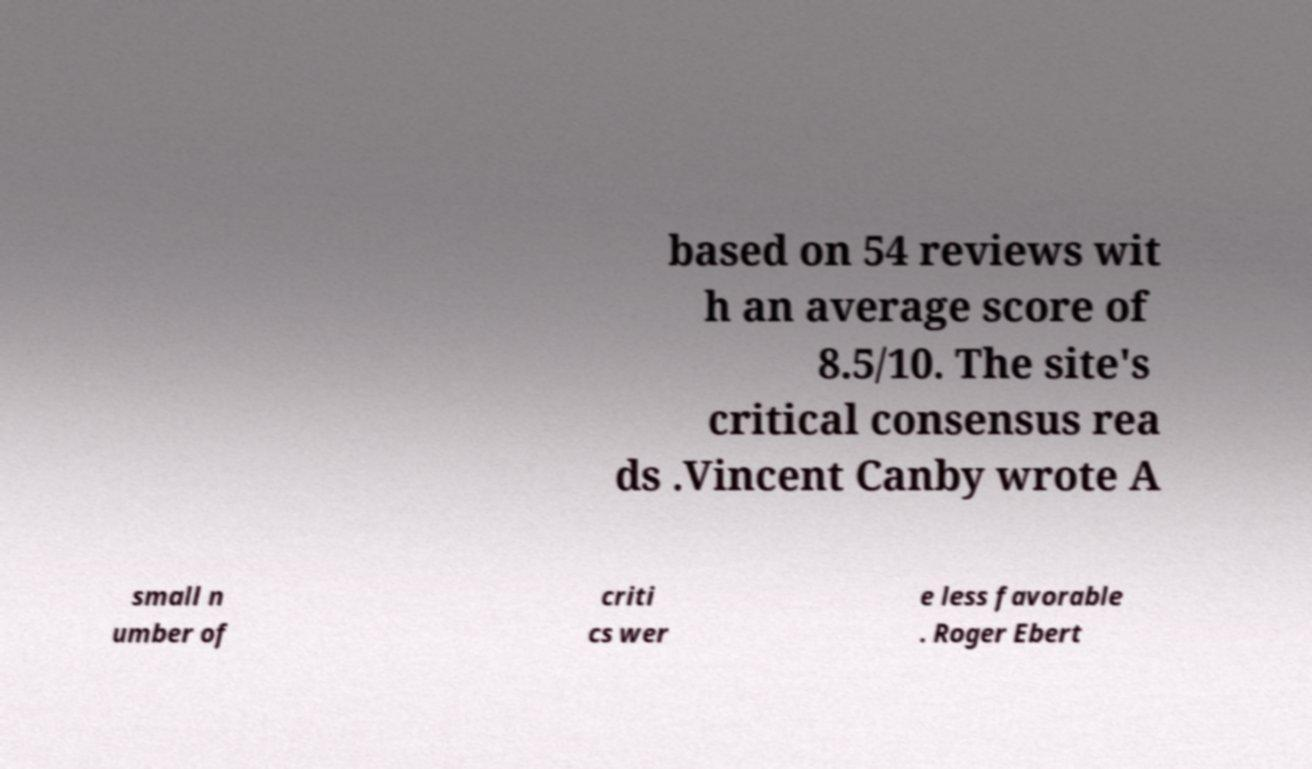What messages or text are displayed in this image? I need them in a readable, typed format. based on 54 reviews wit h an average score of 8.5/10. The site's critical consensus rea ds .Vincent Canby wrote A small n umber of criti cs wer e less favorable . Roger Ebert 